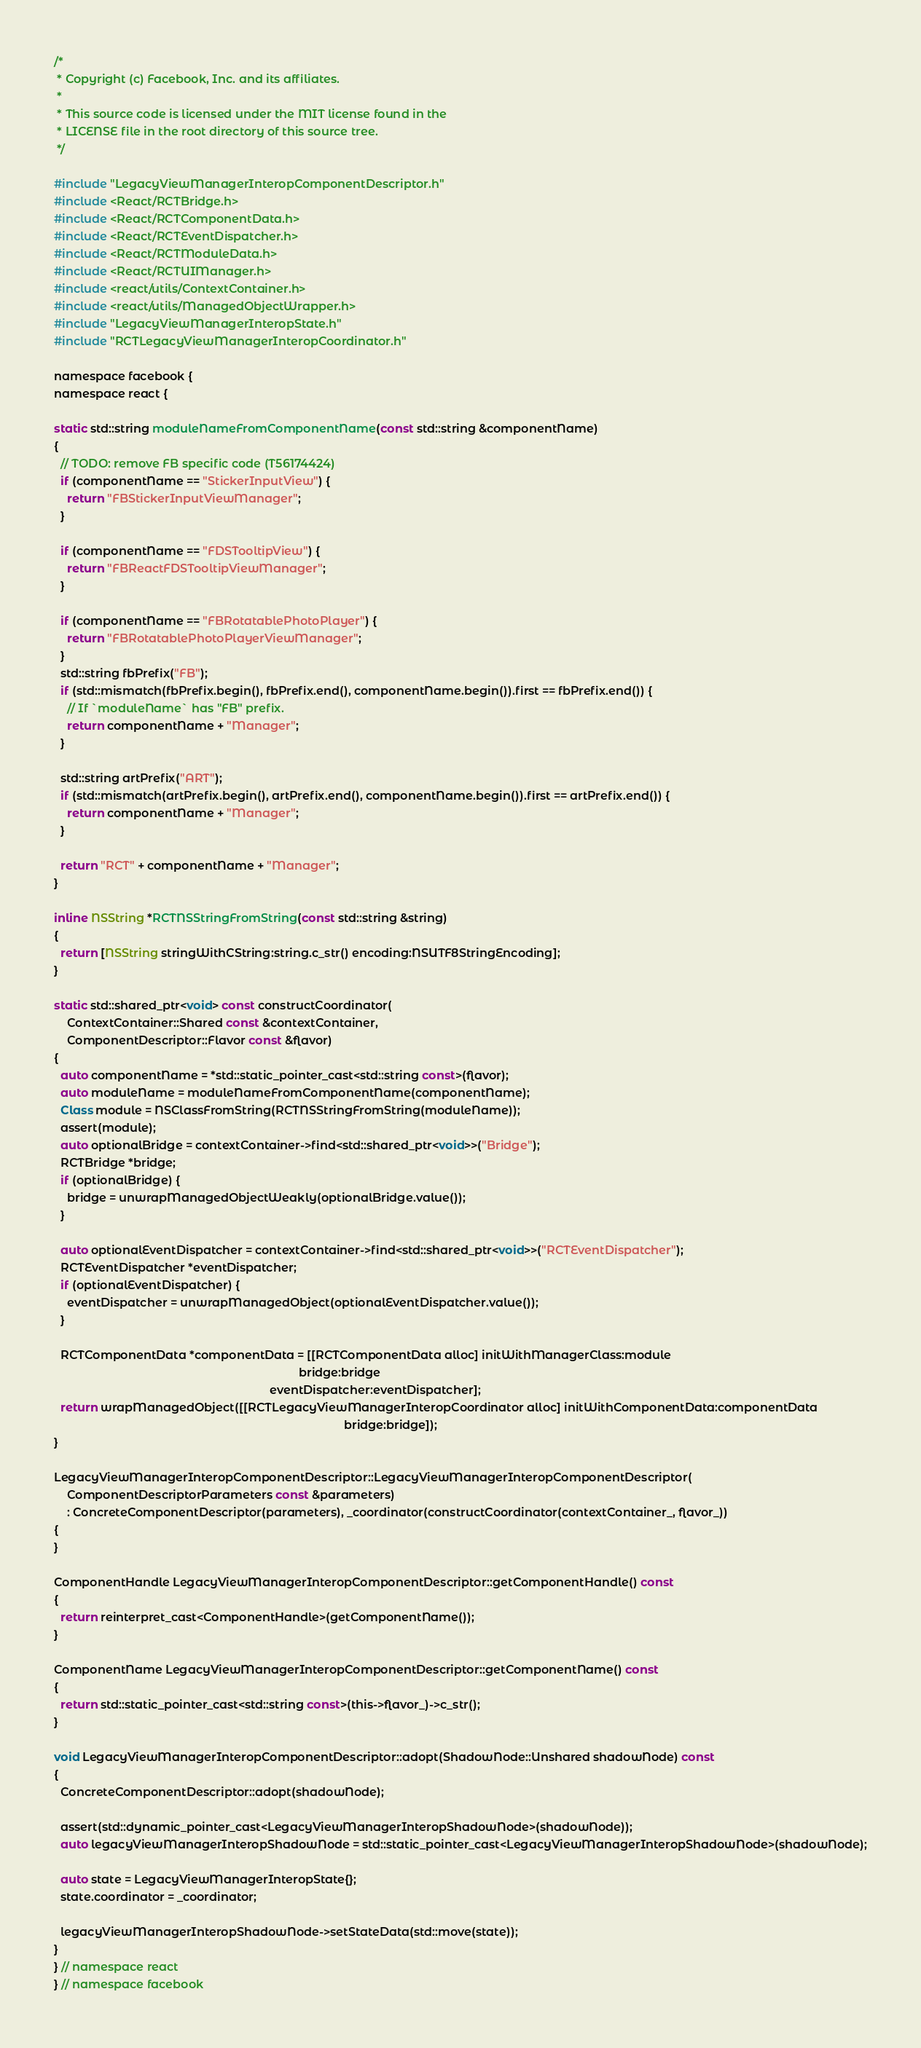<code> <loc_0><loc_0><loc_500><loc_500><_ObjectiveC_>/*
 * Copyright (c) Facebook, Inc. and its affiliates.
 *
 * This source code is licensed under the MIT license found in the
 * LICENSE file in the root directory of this source tree.
 */

#include "LegacyViewManagerInteropComponentDescriptor.h"
#include <React/RCTBridge.h>
#include <React/RCTComponentData.h>
#include <React/RCTEventDispatcher.h>
#include <React/RCTModuleData.h>
#include <React/RCTUIManager.h>
#include <react/utils/ContextContainer.h>
#include <react/utils/ManagedObjectWrapper.h>
#include "LegacyViewManagerInteropState.h"
#include "RCTLegacyViewManagerInteropCoordinator.h"

namespace facebook {
namespace react {

static std::string moduleNameFromComponentName(const std::string &componentName)
{
  // TODO: remove FB specific code (T56174424)
  if (componentName == "StickerInputView") {
    return "FBStickerInputViewManager";
  }

  if (componentName == "FDSTooltipView") {
    return "FBReactFDSTooltipViewManager";
  }

  if (componentName == "FBRotatablePhotoPlayer") {
    return "FBRotatablePhotoPlayerViewManager";
  }
  std::string fbPrefix("FB");
  if (std::mismatch(fbPrefix.begin(), fbPrefix.end(), componentName.begin()).first == fbPrefix.end()) {
    // If `moduleName` has "FB" prefix.
    return componentName + "Manager";
  }

  std::string artPrefix("ART");
  if (std::mismatch(artPrefix.begin(), artPrefix.end(), componentName.begin()).first == artPrefix.end()) {
    return componentName + "Manager";
  }

  return "RCT" + componentName + "Manager";
}

inline NSString *RCTNSStringFromString(const std::string &string)
{
  return [NSString stringWithCString:string.c_str() encoding:NSUTF8StringEncoding];
}

static std::shared_ptr<void> const constructCoordinator(
    ContextContainer::Shared const &contextContainer,
    ComponentDescriptor::Flavor const &flavor)
{
  auto componentName = *std::static_pointer_cast<std::string const>(flavor);
  auto moduleName = moduleNameFromComponentName(componentName);
  Class module = NSClassFromString(RCTNSStringFromString(moduleName));
  assert(module);
  auto optionalBridge = contextContainer->find<std::shared_ptr<void>>("Bridge");
  RCTBridge *bridge;
  if (optionalBridge) {
    bridge = unwrapManagedObjectWeakly(optionalBridge.value());
  }

  auto optionalEventDispatcher = contextContainer->find<std::shared_ptr<void>>("RCTEventDispatcher");
  RCTEventDispatcher *eventDispatcher;
  if (optionalEventDispatcher) {
    eventDispatcher = unwrapManagedObject(optionalEventDispatcher.value());
  }

  RCTComponentData *componentData = [[RCTComponentData alloc] initWithManagerClass:module
                                                                            bridge:bridge
                                                                   eventDispatcher:eventDispatcher];
  return wrapManagedObject([[RCTLegacyViewManagerInteropCoordinator alloc] initWithComponentData:componentData
                                                                                          bridge:bridge]);
}

LegacyViewManagerInteropComponentDescriptor::LegacyViewManagerInteropComponentDescriptor(
    ComponentDescriptorParameters const &parameters)
    : ConcreteComponentDescriptor(parameters), _coordinator(constructCoordinator(contextContainer_, flavor_))
{
}

ComponentHandle LegacyViewManagerInteropComponentDescriptor::getComponentHandle() const
{
  return reinterpret_cast<ComponentHandle>(getComponentName());
}

ComponentName LegacyViewManagerInteropComponentDescriptor::getComponentName() const
{
  return std::static_pointer_cast<std::string const>(this->flavor_)->c_str();
}

void LegacyViewManagerInteropComponentDescriptor::adopt(ShadowNode::Unshared shadowNode) const
{
  ConcreteComponentDescriptor::adopt(shadowNode);

  assert(std::dynamic_pointer_cast<LegacyViewManagerInteropShadowNode>(shadowNode));
  auto legacyViewManagerInteropShadowNode = std::static_pointer_cast<LegacyViewManagerInteropShadowNode>(shadowNode);

  auto state = LegacyViewManagerInteropState{};
  state.coordinator = _coordinator;

  legacyViewManagerInteropShadowNode->setStateData(std::move(state));
}
} // namespace react
} // namespace facebook
</code> 